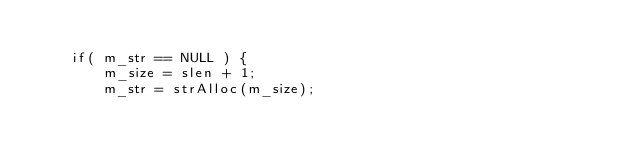<code> <loc_0><loc_0><loc_500><loc_500><_C++_>
	if( m_str == NULL ) {
		m_size = slen + 1;
		m_str = strAlloc(m_size);</code> 